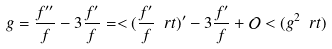<formula> <loc_0><loc_0><loc_500><loc_500>g = \frac { f ^ { \prime \prime } } { f } - 3 \frac { f ^ { \prime } } { f } = < ( \frac { f ^ { \prime } } { f } \ r t ) ^ { \prime } - 3 \frac { f ^ { \prime } } { f } + \mathcal { O } < ( g ^ { 2 } \ r t )</formula> 